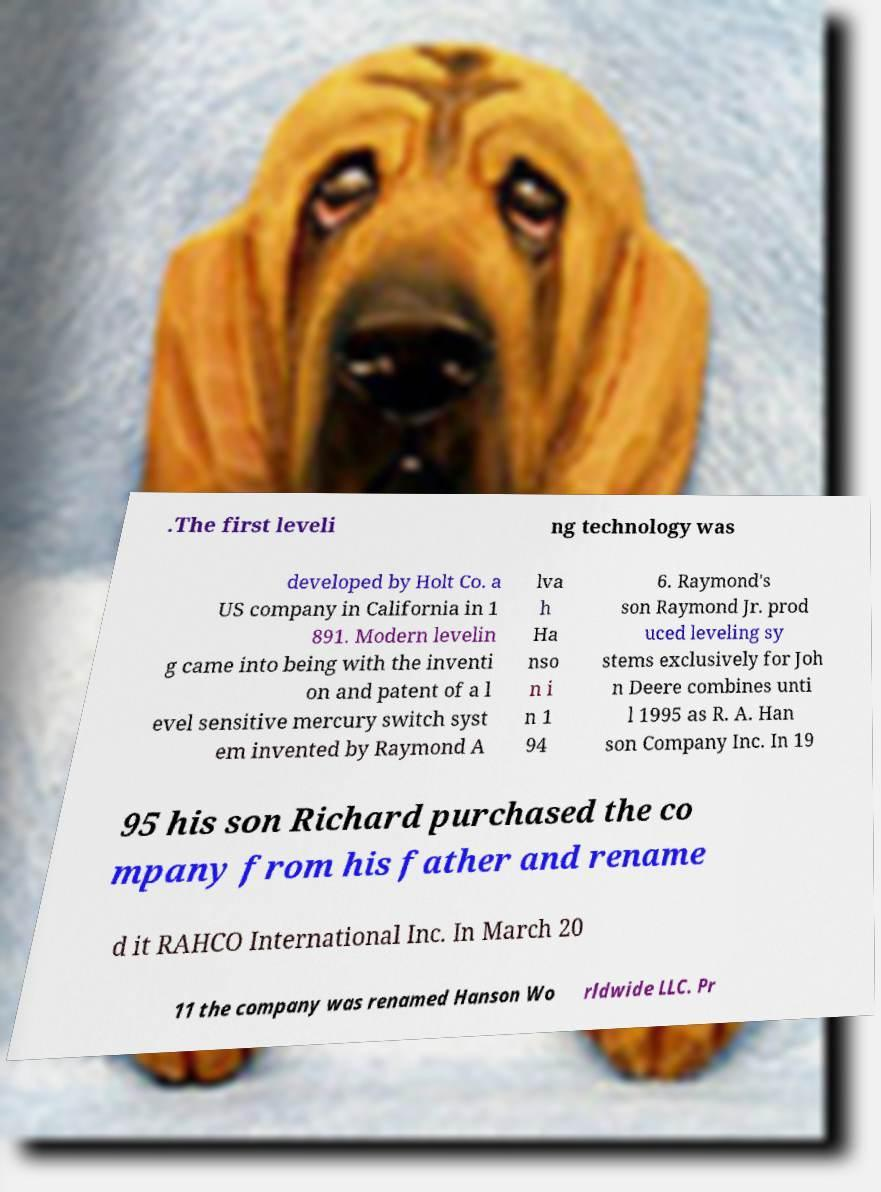Please identify and transcribe the text found in this image. .The first leveli ng technology was developed by Holt Co. a US company in California in 1 891. Modern levelin g came into being with the inventi on and patent of a l evel sensitive mercury switch syst em invented by Raymond A lva h Ha nso n i n 1 94 6. Raymond's son Raymond Jr. prod uced leveling sy stems exclusively for Joh n Deere combines unti l 1995 as R. A. Han son Company Inc. In 19 95 his son Richard purchased the co mpany from his father and rename d it RAHCO International Inc. In March 20 11 the company was renamed Hanson Wo rldwide LLC. Pr 